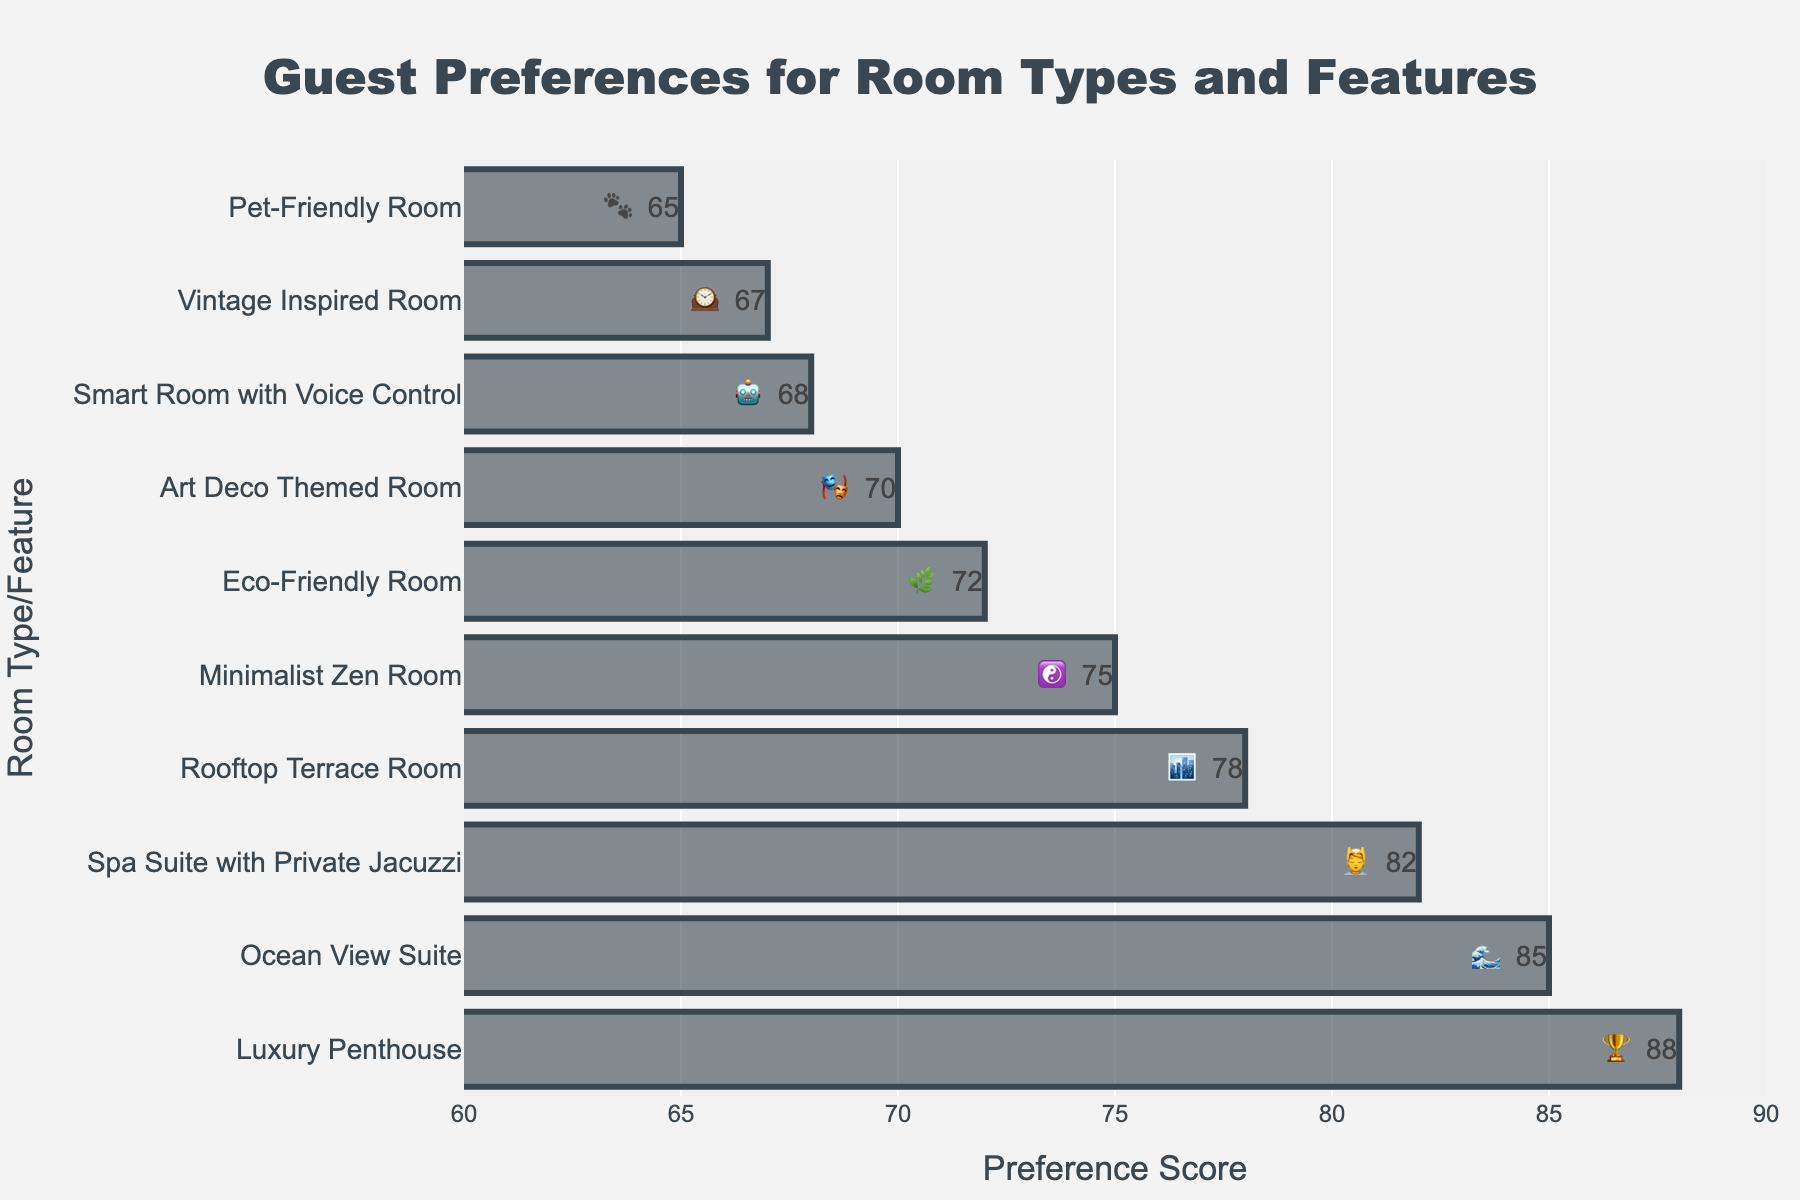What is the title of the chart? The title is displayed at the top of the chart and should clearly describe the information being presented.
Answer: Guest Preferences for Room Types and Features Which room type has the highest preference score? Look for the bar with the greatest length or the highest number on the x-axis.
Answer: Luxury Penthouse Which room type/feature is represented by the emoji 🐾? Identify the row corresponding to the emoji 🐾 in the bar chart.
Answer: Pet-Friendly Room What is the average preference score across all room types? Add up all the preference scores and divide by the number of room types: (85 + 78 + 72 + 68 + 82 + 70 + 65 + 75 + 88 + 67) / 10 = 75
Answer: 75 How do the preference scores of the Ocean View Suite 🌊 and the Rooftop Terrace Room 🏙️ compare? Compare the two scores directly from the chart. Ocean View Suite is 85, and Rooftop Terrace Room is 78.
Answer: Ocean View Suite is higher Between the Minimalist Zen Room ☯️ and the Art Deco Themed Room 🎭, which has a higher preference score? Find the preference scores of both rooms and compare them. Minimalist Zen Room is 75, Art Deco Themed Room is 70.
Answer: Minimalist Zen Room Which room types/feature have a preference score of 70 or greater but less than 80? Identify and list the room types whose scores fall in the range [70, 80).
Answer: Rooftop Terrace Room, Eco-Friendly Room, Art Deco Themed Room, Minimalist Zen Room By how much does the preference score of the Spa Suite with Private Jacuzzi 💆 exceed the preference score of the Pet-Friendly Room 🐾? Subtract the score of Pet-Friendly Room from the score of Spa Suite with Private Jacuzzi: 82 - 65 = 17
Answer: 17 Among the Eco-Friendly Room, 🎭 Art Deco Themed Room, and Smart Room with Voice Control 🤖, which has the lowest preference score? Compare the preference scores of the three room types directly from the chart.
Answer: Smart Room with Voice Control 